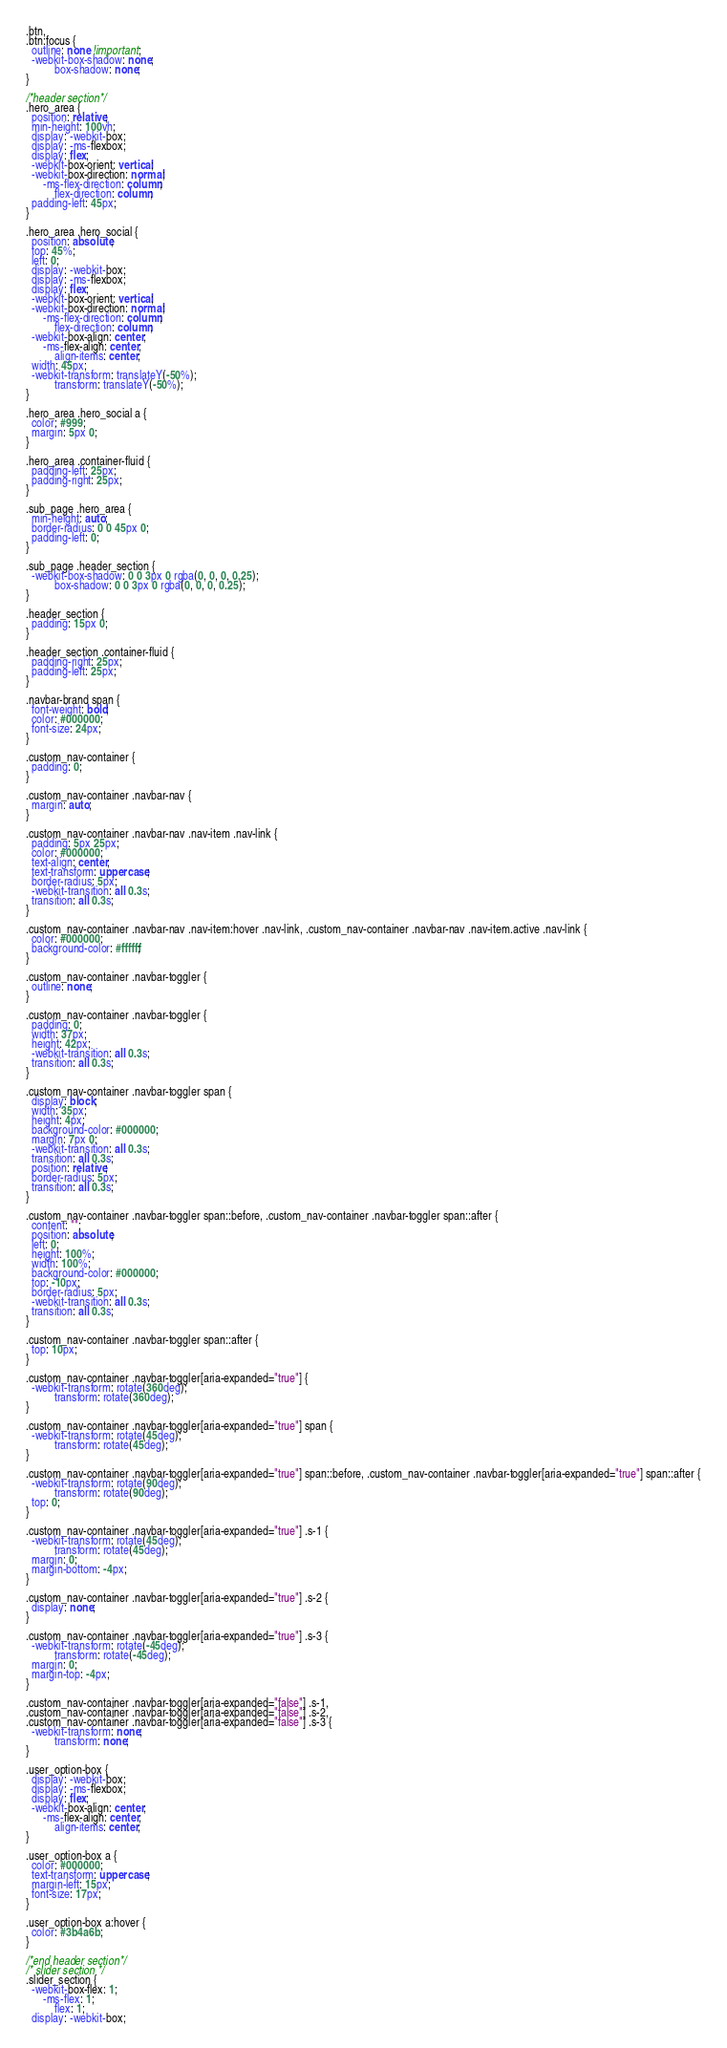Convert code to text. <code><loc_0><loc_0><loc_500><loc_500><_CSS_>
.btn,
.btn:focus {
  outline: none !important;
  -webkit-box-shadow: none;
          box-shadow: none;
}

/*header section*/
.hero_area {
  position: relative;
  min-height: 100vh;
  display: -webkit-box;
  display: -ms-flexbox;
  display: flex;
  -webkit-box-orient: vertical;
  -webkit-box-direction: normal;
      -ms-flex-direction: column;
          flex-direction: column;
  padding-left: 45px;
}

.hero_area .hero_social {
  position: absolute;
  top: 45%;
  left: 0;
  display: -webkit-box;
  display: -ms-flexbox;
  display: flex;
  -webkit-box-orient: vertical;
  -webkit-box-direction: normal;
      -ms-flex-direction: column;
          flex-direction: column;
  -webkit-box-align: center;
      -ms-flex-align: center;
          align-items: center;
  width: 45px;
  -webkit-transform: translateY(-50%);
          transform: translateY(-50%);
}

.hero_area .hero_social a {
  color: #999;
  margin: 5px 0;
}

.hero_area .container-fluid {
  padding-left: 25px;
  padding-right: 25px;
}

.sub_page .hero_area {
  min-height: auto;
  border-radius: 0 0 45px 0;
  padding-left: 0;
}

.sub_page .header_section {
  -webkit-box-shadow: 0 0 3px 0 rgba(0, 0, 0, 0.25);
          box-shadow: 0 0 3px 0 rgba(0, 0, 0, 0.25);
}

.header_section {
  padding: 15px 0;
}

.header_section .container-fluid {
  padding-right: 25px;
  padding-left: 25px;
}

.navbar-brand span {
  font-weight: bold;
  color: #000000;
  font-size: 24px;
}

.custom_nav-container {
  padding: 0;
}

.custom_nav-container .navbar-nav {
  margin: auto;
}

.custom_nav-container .navbar-nav .nav-item .nav-link {
  padding: 5px 25px;
  color: #000000;
  text-align: center;
  text-transform: uppercase;
  border-radius: 5px;
  -webkit-transition: all 0.3s;
  transition: all 0.3s;
}

.custom_nav-container .navbar-nav .nav-item:hover .nav-link, .custom_nav-container .navbar-nav .nav-item.active .nav-link {
  color: #000000;
  background-color: #ffffff;
}

.custom_nav-container .navbar-toggler {
  outline: none;
}

.custom_nav-container .navbar-toggler {
  padding: 0;
  width: 37px;
  height: 42px;
  -webkit-transition: all 0.3s;
  transition: all 0.3s;
}

.custom_nav-container .navbar-toggler span {
  display: block;
  width: 35px;
  height: 4px;
  background-color: #000000;
  margin: 7px 0;
  -webkit-transition: all 0.3s;
  transition: all 0.3s;
  position: relative;
  border-radius: 5px;
  transition: all 0.3s;
}

.custom_nav-container .navbar-toggler span::before, .custom_nav-container .navbar-toggler span::after {
  content: "";
  position: absolute;
  left: 0;
  height: 100%;
  width: 100%;
  background-color: #000000;
  top: -10px;
  border-radius: 5px;
  -webkit-transition: all 0.3s;
  transition: all 0.3s;
}

.custom_nav-container .navbar-toggler span::after {
  top: 10px;
}

.custom_nav-container .navbar-toggler[aria-expanded="true"] {
  -webkit-transform: rotate(360deg);
          transform: rotate(360deg);
}

.custom_nav-container .navbar-toggler[aria-expanded="true"] span {
  -webkit-transform: rotate(45deg);
          transform: rotate(45deg);
}

.custom_nav-container .navbar-toggler[aria-expanded="true"] span::before, .custom_nav-container .navbar-toggler[aria-expanded="true"] span::after {
  -webkit-transform: rotate(90deg);
          transform: rotate(90deg);
  top: 0;
}

.custom_nav-container .navbar-toggler[aria-expanded="true"] .s-1 {
  -webkit-transform: rotate(45deg);
          transform: rotate(45deg);
  margin: 0;
  margin-bottom: -4px;
}

.custom_nav-container .navbar-toggler[aria-expanded="true"] .s-2 {
  display: none;
}

.custom_nav-container .navbar-toggler[aria-expanded="true"] .s-3 {
  -webkit-transform: rotate(-45deg);
          transform: rotate(-45deg);
  margin: 0;
  margin-top: -4px;
}

.custom_nav-container .navbar-toggler[aria-expanded="false"] .s-1,
.custom_nav-container .navbar-toggler[aria-expanded="false"] .s-2,
.custom_nav-container .navbar-toggler[aria-expanded="false"] .s-3 {
  -webkit-transform: none;
          transform: none;
}

.user_option-box {
  display: -webkit-box;
  display: -ms-flexbox;
  display: flex;
  -webkit-box-align: center;
      -ms-flex-align: center;
          align-items: center;
}

.user_option-box a {
  color: #000000;
  text-transform: uppercase;
  margin-left: 15px;
  font-size: 17px;
}

.user_option-box a:hover {
  color: #3b4a6b;
}

/*end header section*/
/* slider section */
.slider_section {
  -webkit-box-flex: 1;
      -ms-flex: 1;
          flex: 1;
  display: -webkit-box;</code> 